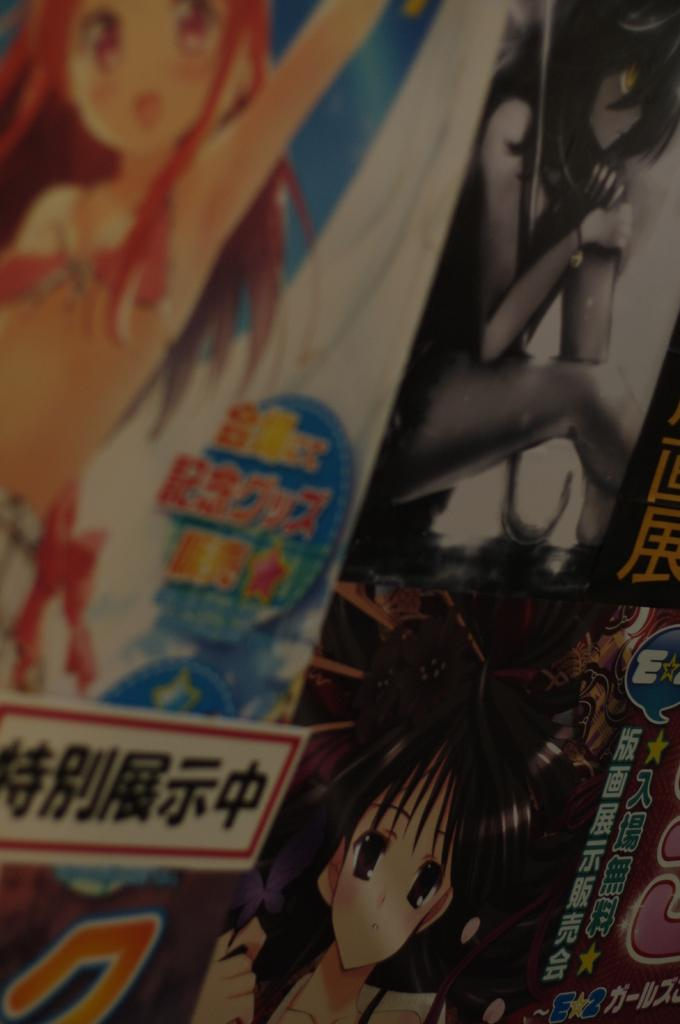What is present in the image that contains both text and images? There is a poster in the image that contains text and cartoon pictures. Can you see a dog interacting with the zebra on the poster in the image? There is no dog or zebra present on the poster in the image; it contains text and cartoon pictures. 